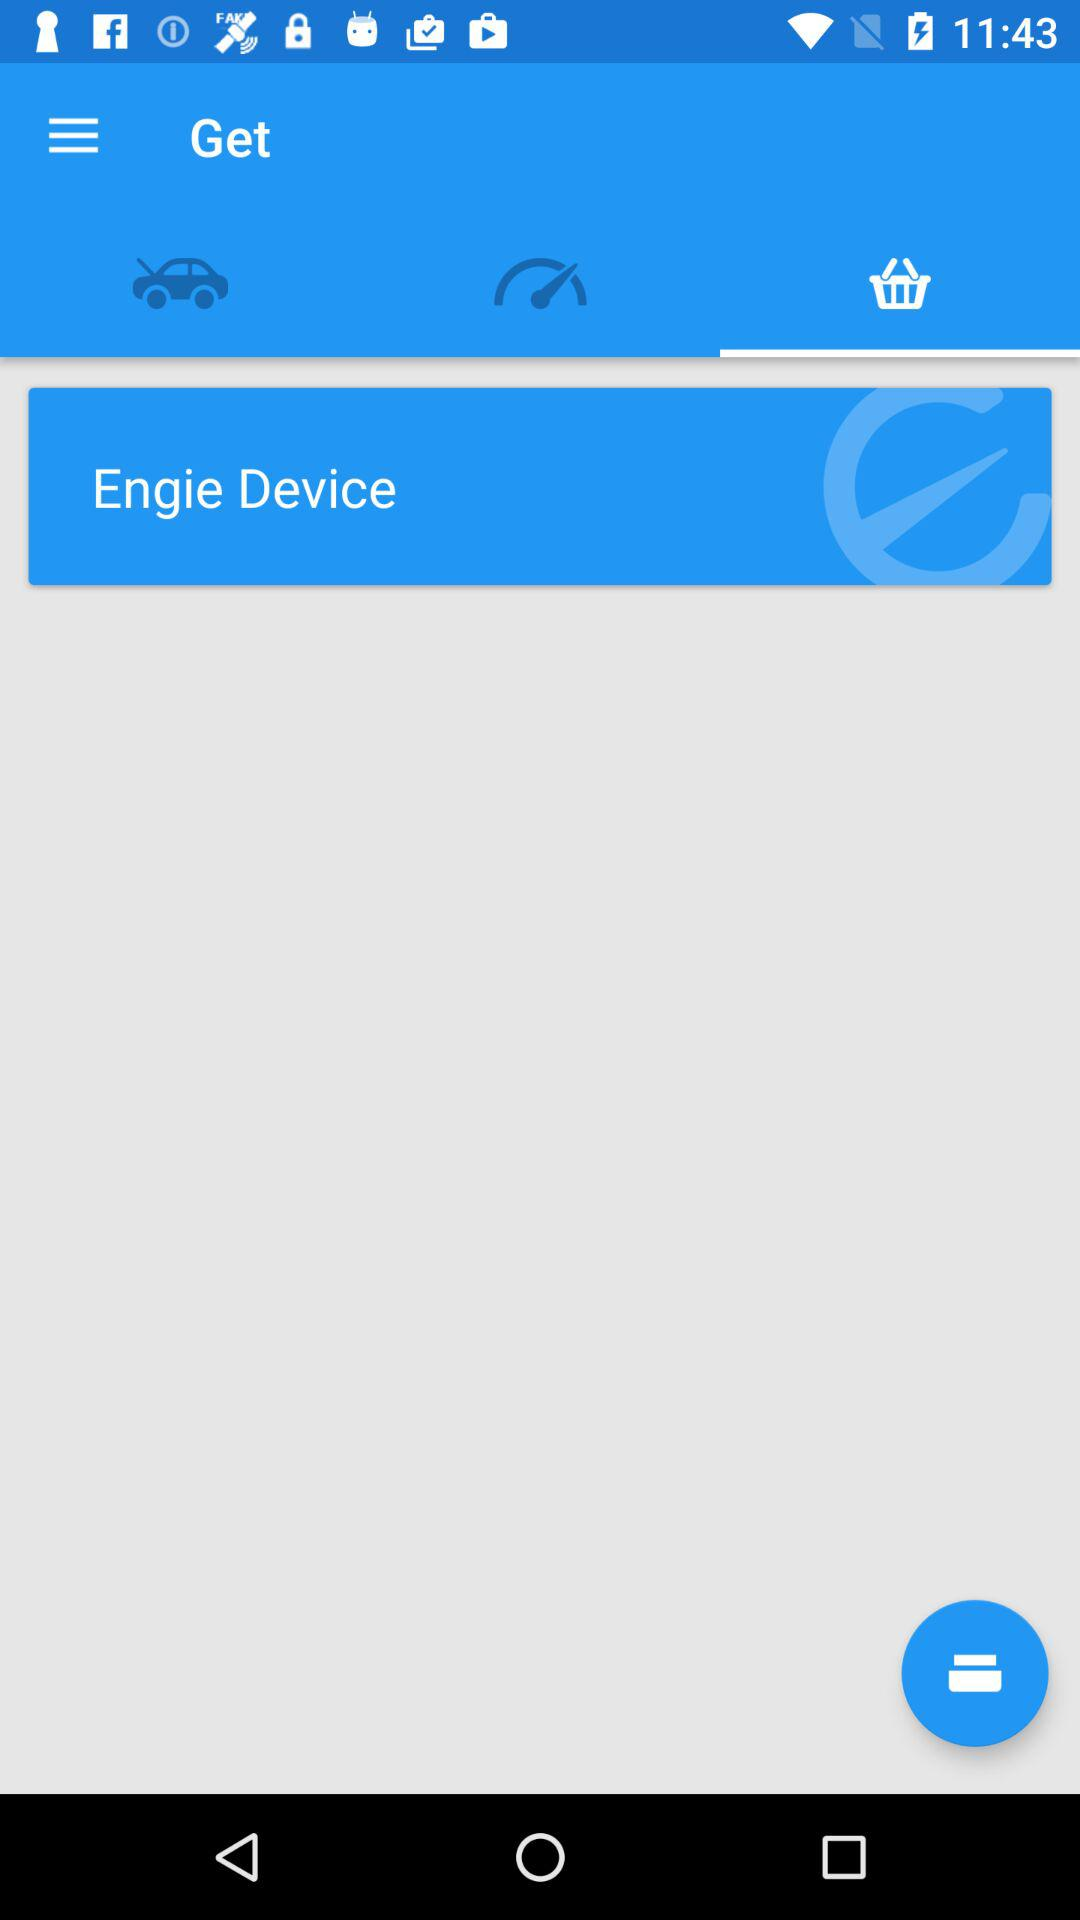When was the car last serviced?
When the provided information is insufficient, respond with <no answer>. <no answer> 